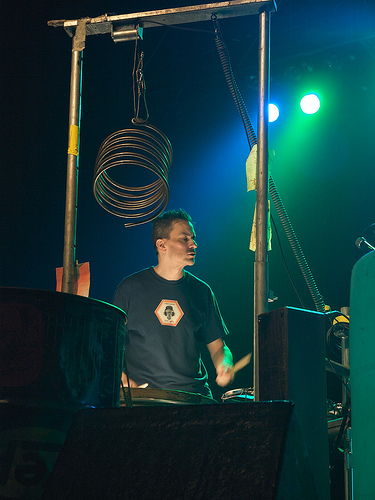<image>
Is the coil behind the man? No. The coil is not behind the man. From this viewpoint, the coil appears to be positioned elsewhere in the scene. 